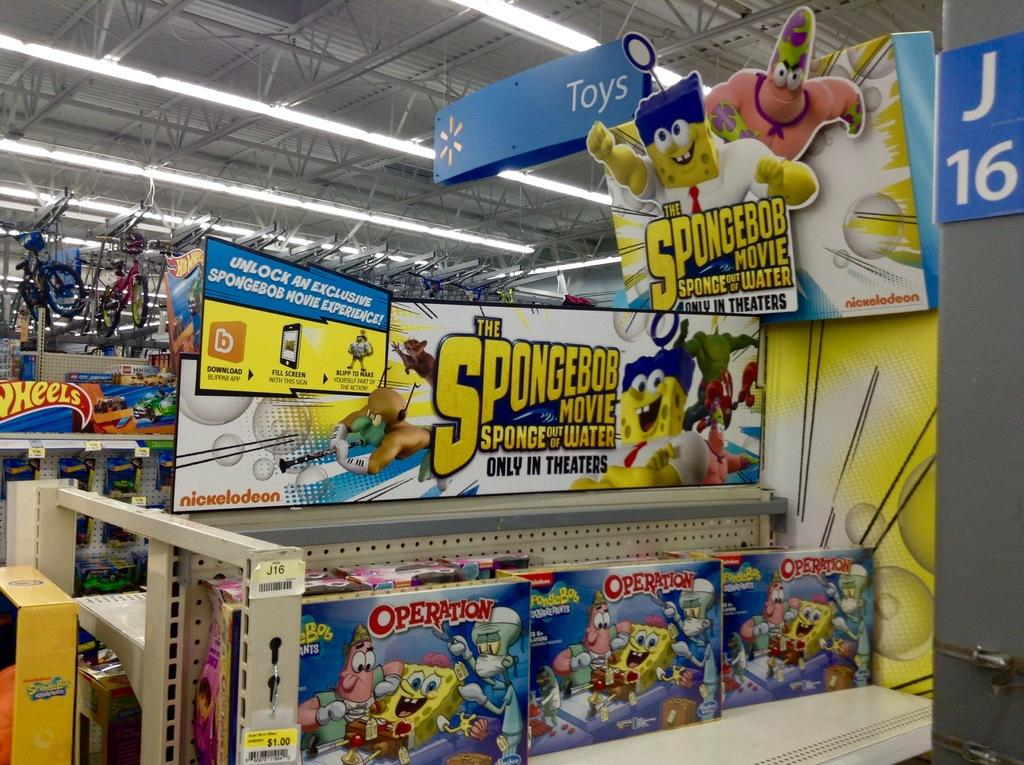<image>
Relay a brief, clear account of the picture shown. Spongebob version of Operation is displayed at a store. 